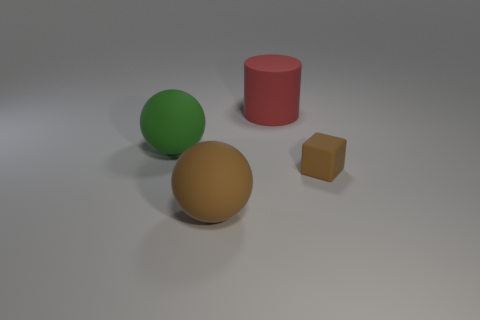There is a object that is behind the green ball; what is its size?
Offer a very short reply. Large. What number of things are objects right of the large red cylinder or big rubber things in front of the big red cylinder?
Make the answer very short. 3. Are there any other things of the same color as the matte cube?
Offer a very short reply. Yes. Are there an equal number of small matte things right of the red matte thing and big red things behind the small brown rubber thing?
Give a very brief answer. Yes. Are there more rubber things that are behind the brown rubber block than big yellow blocks?
Ensure brevity in your answer.  Yes. What number of objects are rubber things that are right of the large green sphere or tiny rubber things?
Give a very brief answer. 3. How many tiny purple balls are made of the same material as the small cube?
Offer a terse response. 0. Is there another tiny brown rubber object that has the same shape as the tiny brown thing?
Ensure brevity in your answer.  No. The brown matte object that is the same size as the green rubber sphere is what shape?
Offer a very short reply. Sphere. There is a small rubber cube; is its color the same as the big rubber ball in front of the cube?
Your answer should be very brief. Yes. 